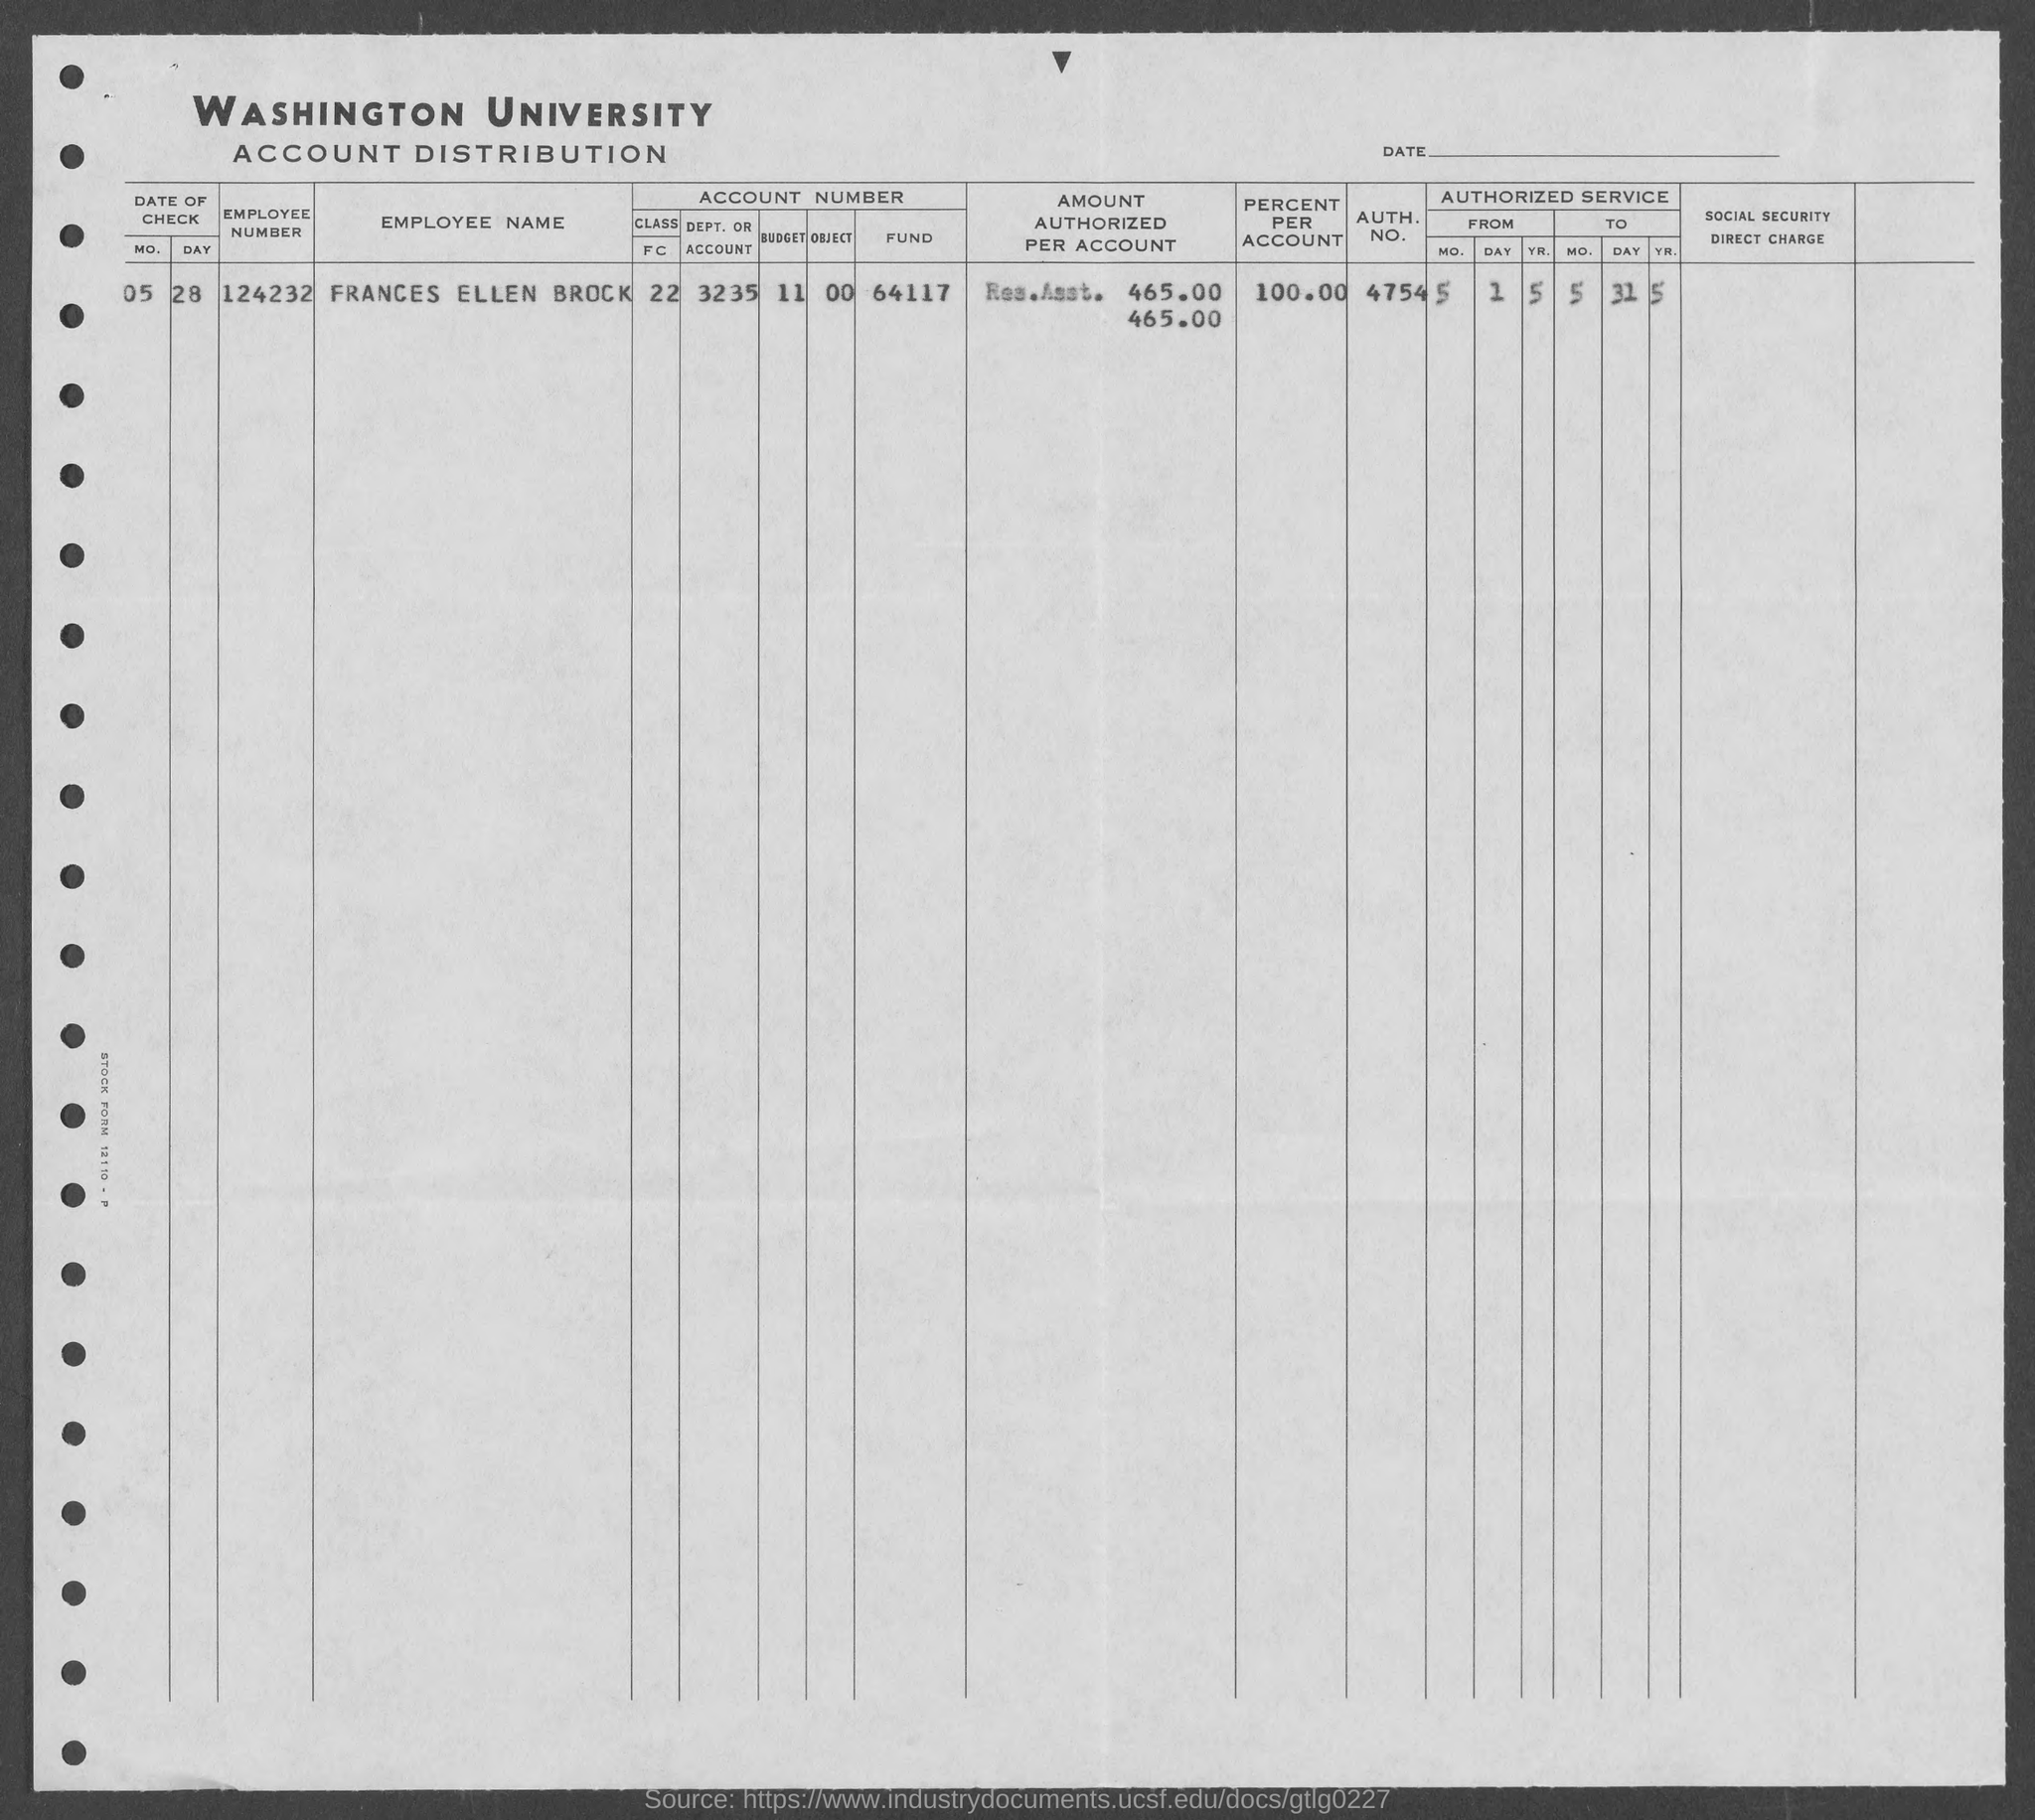Which university is mentioned in the letterhead?
Your response must be concise. WASHINGTON UNIVERSITY. What is the employee number?
Offer a terse response. 124232. How much is the percent per account?
Keep it short and to the point. 100.00. Which is the AUTH. NO.?
Your answer should be very brief. 4754. 